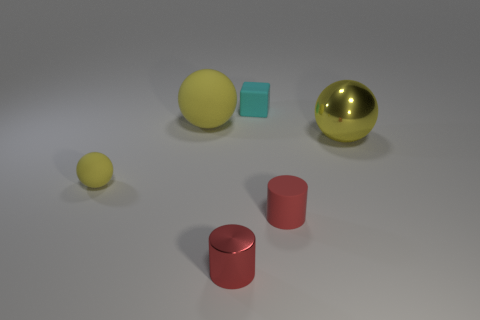Is the number of red metallic cylinders behind the small cube the same as the number of tiny brown cylinders?
Your response must be concise. Yes. Are there any cubes of the same size as the cyan thing?
Make the answer very short. No. There is a yellow shiny sphere; is its size the same as the rubber sphere to the right of the small sphere?
Your answer should be compact. Yes. Are there the same number of big yellow metallic things that are left of the big yellow metal sphere and yellow balls that are behind the cyan rubber cube?
Your response must be concise. Yes. What is the shape of the metallic object that is the same color as the large matte ball?
Make the answer very short. Sphere. There is a red cylinder on the left side of the rubber cylinder; what is it made of?
Offer a very short reply. Metal. Is the size of the metal cylinder the same as the cyan block?
Offer a terse response. Yes. Are there more rubber cylinders that are on the right side of the small cyan thing than tiny purple matte blocks?
Keep it short and to the point. Yes. There is a red thing that is the same material as the block; what is its size?
Provide a succinct answer. Small. Are there any red shiny things in front of the small cyan rubber thing?
Your response must be concise. Yes. 